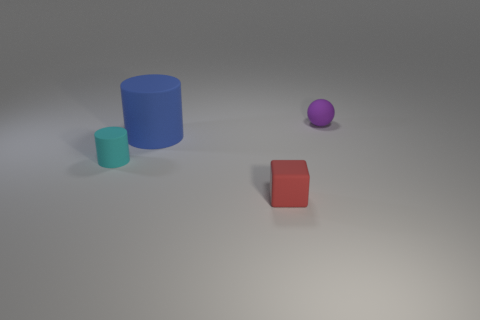Add 3 tiny cyan things. How many objects exist? 7 Subtract 2 cylinders. How many cylinders are left? 0 Subtract all cyan blocks. Subtract all brown balls. How many blocks are left? 1 Subtract all green cylinders. How many green cubes are left? 0 Subtract all large metal things. Subtract all purple balls. How many objects are left? 3 Add 2 tiny objects. How many tiny objects are left? 5 Add 1 big cyan matte cylinders. How many big cyan matte cylinders exist? 1 Subtract 0 gray cylinders. How many objects are left? 4 